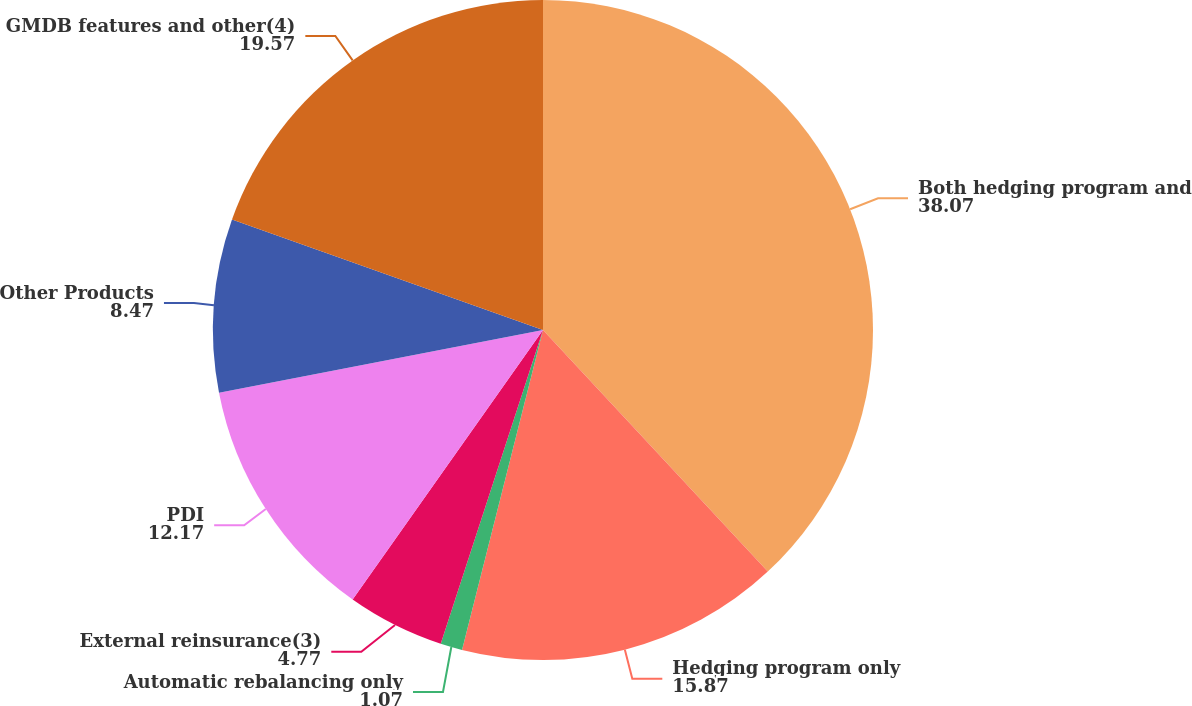Convert chart to OTSL. <chart><loc_0><loc_0><loc_500><loc_500><pie_chart><fcel>Both hedging program and<fcel>Hedging program only<fcel>Automatic rebalancing only<fcel>External reinsurance(3)<fcel>PDI<fcel>Other Products<fcel>GMDB features and other(4)<nl><fcel>38.07%<fcel>15.87%<fcel>1.07%<fcel>4.77%<fcel>12.17%<fcel>8.47%<fcel>19.57%<nl></chart> 